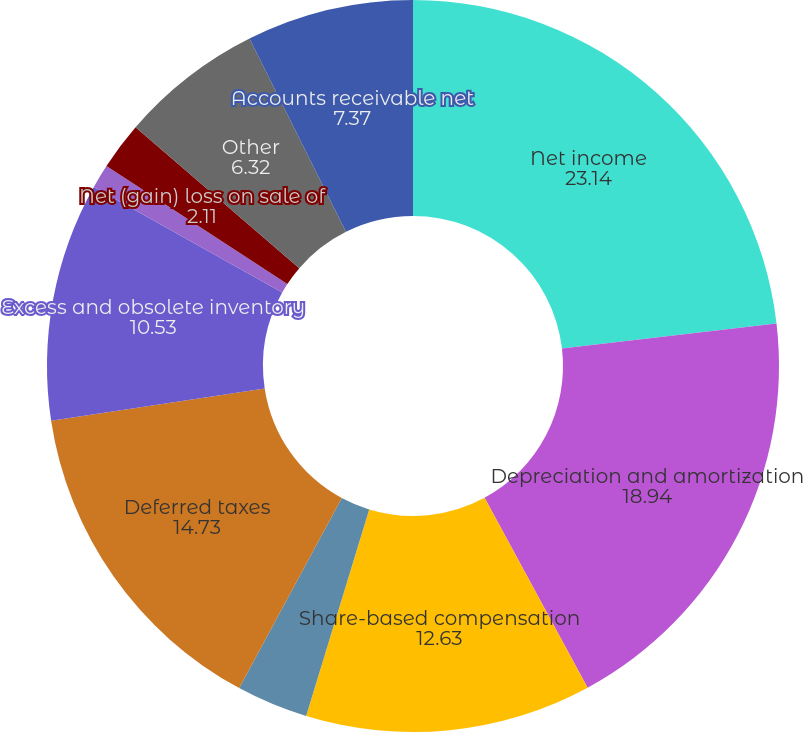Convert chart to OTSL. <chart><loc_0><loc_0><loc_500><loc_500><pie_chart><fcel>Net income<fcel>Depreciation and amortization<fcel>Share-based compensation<fcel>Excess tax benefit from<fcel>Deferred taxes<fcel>Excess and obsolete inventory<fcel>Non-cash restructuring and<fcel>Net (gain) loss on sale of<fcel>Other<fcel>Accounts receivable net<nl><fcel>23.14%<fcel>18.94%<fcel>12.63%<fcel>3.16%<fcel>14.73%<fcel>10.53%<fcel>1.06%<fcel>2.11%<fcel>6.32%<fcel>7.37%<nl></chart> 